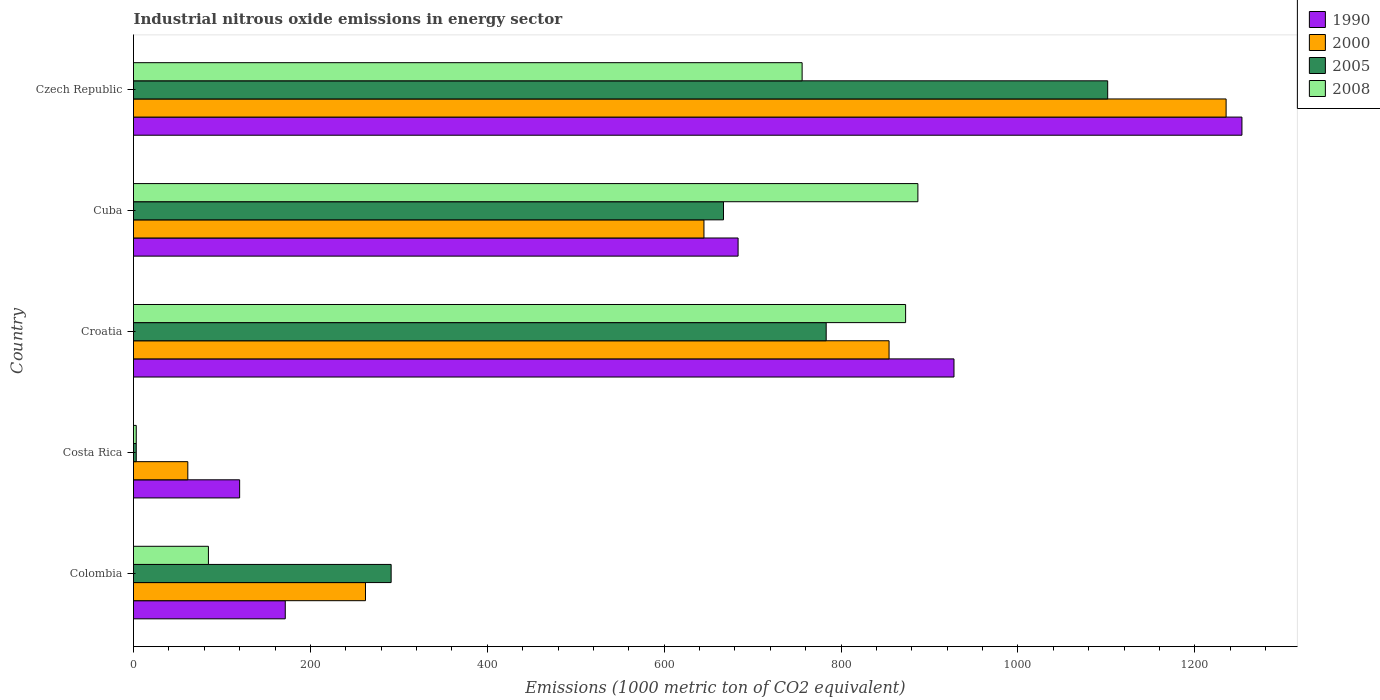How many different coloured bars are there?
Your response must be concise. 4. How many groups of bars are there?
Make the answer very short. 5. Are the number of bars on each tick of the Y-axis equal?
Your response must be concise. Yes. How many bars are there on the 5th tick from the top?
Provide a succinct answer. 4. What is the amount of industrial nitrous oxide emitted in 2005 in Croatia?
Offer a very short reply. 783.2. Across all countries, what is the maximum amount of industrial nitrous oxide emitted in 2005?
Offer a terse response. 1101.5. In which country was the amount of industrial nitrous oxide emitted in 1990 maximum?
Give a very brief answer. Czech Republic. In which country was the amount of industrial nitrous oxide emitted in 2000 minimum?
Your response must be concise. Costa Rica. What is the total amount of industrial nitrous oxide emitted in 1990 in the graph?
Give a very brief answer. 3156.2. What is the difference between the amount of industrial nitrous oxide emitted in 2008 in Colombia and that in Costa Rica?
Offer a very short reply. 81.6. What is the difference between the amount of industrial nitrous oxide emitted in 2000 in Croatia and the amount of industrial nitrous oxide emitted in 2008 in Cuba?
Your answer should be compact. -32.6. What is the average amount of industrial nitrous oxide emitted in 1990 per country?
Make the answer very short. 631.24. What is the difference between the amount of industrial nitrous oxide emitted in 1990 and amount of industrial nitrous oxide emitted in 2000 in Colombia?
Offer a terse response. -90.7. In how many countries, is the amount of industrial nitrous oxide emitted in 2008 greater than 1240 1000 metric ton?
Ensure brevity in your answer.  0. What is the ratio of the amount of industrial nitrous oxide emitted in 2008 in Costa Rica to that in Croatia?
Provide a short and direct response. 0. Is the difference between the amount of industrial nitrous oxide emitted in 1990 in Croatia and Cuba greater than the difference between the amount of industrial nitrous oxide emitted in 2000 in Croatia and Cuba?
Offer a very short reply. Yes. What is the difference between the highest and the second highest amount of industrial nitrous oxide emitted in 1990?
Provide a short and direct response. 325.6. What is the difference between the highest and the lowest amount of industrial nitrous oxide emitted in 2000?
Give a very brief answer. 1174. Is the sum of the amount of industrial nitrous oxide emitted in 2000 in Croatia and Czech Republic greater than the maximum amount of industrial nitrous oxide emitted in 2005 across all countries?
Give a very brief answer. Yes. What does the 3rd bar from the bottom in Colombia represents?
Keep it short and to the point. 2005. What is the difference between two consecutive major ticks on the X-axis?
Give a very brief answer. 200. What is the title of the graph?
Ensure brevity in your answer.  Industrial nitrous oxide emissions in energy sector. Does "1966" appear as one of the legend labels in the graph?
Provide a succinct answer. No. What is the label or title of the X-axis?
Provide a short and direct response. Emissions (1000 metric ton of CO2 equivalent). What is the label or title of the Y-axis?
Your response must be concise. Country. What is the Emissions (1000 metric ton of CO2 equivalent) of 1990 in Colombia?
Provide a succinct answer. 171.6. What is the Emissions (1000 metric ton of CO2 equivalent) in 2000 in Colombia?
Make the answer very short. 262.3. What is the Emissions (1000 metric ton of CO2 equivalent) of 2005 in Colombia?
Your answer should be very brief. 291.3. What is the Emissions (1000 metric ton of CO2 equivalent) of 2008 in Colombia?
Give a very brief answer. 84.7. What is the Emissions (1000 metric ton of CO2 equivalent) in 1990 in Costa Rica?
Provide a short and direct response. 120. What is the Emissions (1000 metric ton of CO2 equivalent) of 2000 in Costa Rica?
Your answer should be compact. 61.4. What is the Emissions (1000 metric ton of CO2 equivalent) in 1990 in Croatia?
Give a very brief answer. 927.7. What is the Emissions (1000 metric ton of CO2 equivalent) in 2000 in Croatia?
Provide a short and direct response. 854.3. What is the Emissions (1000 metric ton of CO2 equivalent) in 2005 in Croatia?
Provide a short and direct response. 783.2. What is the Emissions (1000 metric ton of CO2 equivalent) in 2008 in Croatia?
Provide a short and direct response. 873. What is the Emissions (1000 metric ton of CO2 equivalent) in 1990 in Cuba?
Provide a short and direct response. 683.6. What is the Emissions (1000 metric ton of CO2 equivalent) of 2000 in Cuba?
Make the answer very short. 645. What is the Emissions (1000 metric ton of CO2 equivalent) in 2005 in Cuba?
Ensure brevity in your answer.  667.1. What is the Emissions (1000 metric ton of CO2 equivalent) of 2008 in Cuba?
Your response must be concise. 886.9. What is the Emissions (1000 metric ton of CO2 equivalent) in 1990 in Czech Republic?
Make the answer very short. 1253.3. What is the Emissions (1000 metric ton of CO2 equivalent) of 2000 in Czech Republic?
Your answer should be very brief. 1235.4. What is the Emissions (1000 metric ton of CO2 equivalent) of 2005 in Czech Republic?
Your answer should be very brief. 1101.5. What is the Emissions (1000 metric ton of CO2 equivalent) in 2008 in Czech Republic?
Keep it short and to the point. 756. Across all countries, what is the maximum Emissions (1000 metric ton of CO2 equivalent) in 1990?
Your answer should be compact. 1253.3. Across all countries, what is the maximum Emissions (1000 metric ton of CO2 equivalent) in 2000?
Offer a terse response. 1235.4. Across all countries, what is the maximum Emissions (1000 metric ton of CO2 equivalent) in 2005?
Give a very brief answer. 1101.5. Across all countries, what is the maximum Emissions (1000 metric ton of CO2 equivalent) of 2008?
Provide a short and direct response. 886.9. Across all countries, what is the minimum Emissions (1000 metric ton of CO2 equivalent) in 1990?
Provide a succinct answer. 120. Across all countries, what is the minimum Emissions (1000 metric ton of CO2 equivalent) of 2000?
Offer a terse response. 61.4. Across all countries, what is the minimum Emissions (1000 metric ton of CO2 equivalent) of 2008?
Give a very brief answer. 3.1. What is the total Emissions (1000 metric ton of CO2 equivalent) in 1990 in the graph?
Keep it short and to the point. 3156.2. What is the total Emissions (1000 metric ton of CO2 equivalent) of 2000 in the graph?
Your response must be concise. 3058.4. What is the total Emissions (1000 metric ton of CO2 equivalent) in 2005 in the graph?
Offer a terse response. 2846.2. What is the total Emissions (1000 metric ton of CO2 equivalent) in 2008 in the graph?
Give a very brief answer. 2603.7. What is the difference between the Emissions (1000 metric ton of CO2 equivalent) in 1990 in Colombia and that in Costa Rica?
Give a very brief answer. 51.6. What is the difference between the Emissions (1000 metric ton of CO2 equivalent) of 2000 in Colombia and that in Costa Rica?
Make the answer very short. 200.9. What is the difference between the Emissions (1000 metric ton of CO2 equivalent) in 2005 in Colombia and that in Costa Rica?
Give a very brief answer. 288.2. What is the difference between the Emissions (1000 metric ton of CO2 equivalent) of 2008 in Colombia and that in Costa Rica?
Provide a succinct answer. 81.6. What is the difference between the Emissions (1000 metric ton of CO2 equivalent) in 1990 in Colombia and that in Croatia?
Your response must be concise. -756.1. What is the difference between the Emissions (1000 metric ton of CO2 equivalent) in 2000 in Colombia and that in Croatia?
Offer a very short reply. -592. What is the difference between the Emissions (1000 metric ton of CO2 equivalent) of 2005 in Colombia and that in Croatia?
Provide a short and direct response. -491.9. What is the difference between the Emissions (1000 metric ton of CO2 equivalent) in 2008 in Colombia and that in Croatia?
Ensure brevity in your answer.  -788.3. What is the difference between the Emissions (1000 metric ton of CO2 equivalent) in 1990 in Colombia and that in Cuba?
Give a very brief answer. -512. What is the difference between the Emissions (1000 metric ton of CO2 equivalent) of 2000 in Colombia and that in Cuba?
Make the answer very short. -382.7. What is the difference between the Emissions (1000 metric ton of CO2 equivalent) of 2005 in Colombia and that in Cuba?
Offer a very short reply. -375.8. What is the difference between the Emissions (1000 metric ton of CO2 equivalent) in 2008 in Colombia and that in Cuba?
Make the answer very short. -802.2. What is the difference between the Emissions (1000 metric ton of CO2 equivalent) of 1990 in Colombia and that in Czech Republic?
Ensure brevity in your answer.  -1081.7. What is the difference between the Emissions (1000 metric ton of CO2 equivalent) in 2000 in Colombia and that in Czech Republic?
Ensure brevity in your answer.  -973.1. What is the difference between the Emissions (1000 metric ton of CO2 equivalent) in 2005 in Colombia and that in Czech Republic?
Provide a short and direct response. -810.2. What is the difference between the Emissions (1000 metric ton of CO2 equivalent) of 2008 in Colombia and that in Czech Republic?
Ensure brevity in your answer.  -671.3. What is the difference between the Emissions (1000 metric ton of CO2 equivalent) of 1990 in Costa Rica and that in Croatia?
Offer a very short reply. -807.7. What is the difference between the Emissions (1000 metric ton of CO2 equivalent) of 2000 in Costa Rica and that in Croatia?
Your response must be concise. -792.9. What is the difference between the Emissions (1000 metric ton of CO2 equivalent) in 2005 in Costa Rica and that in Croatia?
Provide a succinct answer. -780.1. What is the difference between the Emissions (1000 metric ton of CO2 equivalent) in 2008 in Costa Rica and that in Croatia?
Your response must be concise. -869.9. What is the difference between the Emissions (1000 metric ton of CO2 equivalent) of 1990 in Costa Rica and that in Cuba?
Make the answer very short. -563.6. What is the difference between the Emissions (1000 metric ton of CO2 equivalent) in 2000 in Costa Rica and that in Cuba?
Your answer should be compact. -583.6. What is the difference between the Emissions (1000 metric ton of CO2 equivalent) in 2005 in Costa Rica and that in Cuba?
Make the answer very short. -664. What is the difference between the Emissions (1000 metric ton of CO2 equivalent) in 2008 in Costa Rica and that in Cuba?
Provide a succinct answer. -883.8. What is the difference between the Emissions (1000 metric ton of CO2 equivalent) in 1990 in Costa Rica and that in Czech Republic?
Give a very brief answer. -1133.3. What is the difference between the Emissions (1000 metric ton of CO2 equivalent) in 2000 in Costa Rica and that in Czech Republic?
Provide a short and direct response. -1174. What is the difference between the Emissions (1000 metric ton of CO2 equivalent) in 2005 in Costa Rica and that in Czech Republic?
Your answer should be compact. -1098.4. What is the difference between the Emissions (1000 metric ton of CO2 equivalent) of 2008 in Costa Rica and that in Czech Republic?
Provide a short and direct response. -752.9. What is the difference between the Emissions (1000 metric ton of CO2 equivalent) in 1990 in Croatia and that in Cuba?
Your response must be concise. 244.1. What is the difference between the Emissions (1000 metric ton of CO2 equivalent) in 2000 in Croatia and that in Cuba?
Provide a short and direct response. 209.3. What is the difference between the Emissions (1000 metric ton of CO2 equivalent) of 2005 in Croatia and that in Cuba?
Your response must be concise. 116.1. What is the difference between the Emissions (1000 metric ton of CO2 equivalent) of 2008 in Croatia and that in Cuba?
Provide a short and direct response. -13.9. What is the difference between the Emissions (1000 metric ton of CO2 equivalent) in 1990 in Croatia and that in Czech Republic?
Make the answer very short. -325.6. What is the difference between the Emissions (1000 metric ton of CO2 equivalent) of 2000 in Croatia and that in Czech Republic?
Provide a succinct answer. -381.1. What is the difference between the Emissions (1000 metric ton of CO2 equivalent) in 2005 in Croatia and that in Czech Republic?
Make the answer very short. -318.3. What is the difference between the Emissions (1000 metric ton of CO2 equivalent) of 2008 in Croatia and that in Czech Republic?
Provide a succinct answer. 117. What is the difference between the Emissions (1000 metric ton of CO2 equivalent) of 1990 in Cuba and that in Czech Republic?
Your answer should be compact. -569.7. What is the difference between the Emissions (1000 metric ton of CO2 equivalent) of 2000 in Cuba and that in Czech Republic?
Keep it short and to the point. -590.4. What is the difference between the Emissions (1000 metric ton of CO2 equivalent) of 2005 in Cuba and that in Czech Republic?
Offer a very short reply. -434.4. What is the difference between the Emissions (1000 metric ton of CO2 equivalent) in 2008 in Cuba and that in Czech Republic?
Provide a short and direct response. 130.9. What is the difference between the Emissions (1000 metric ton of CO2 equivalent) of 1990 in Colombia and the Emissions (1000 metric ton of CO2 equivalent) of 2000 in Costa Rica?
Ensure brevity in your answer.  110.2. What is the difference between the Emissions (1000 metric ton of CO2 equivalent) of 1990 in Colombia and the Emissions (1000 metric ton of CO2 equivalent) of 2005 in Costa Rica?
Offer a very short reply. 168.5. What is the difference between the Emissions (1000 metric ton of CO2 equivalent) in 1990 in Colombia and the Emissions (1000 metric ton of CO2 equivalent) in 2008 in Costa Rica?
Keep it short and to the point. 168.5. What is the difference between the Emissions (1000 metric ton of CO2 equivalent) in 2000 in Colombia and the Emissions (1000 metric ton of CO2 equivalent) in 2005 in Costa Rica?
Ensure brevity in your answer.  259.2. What is the difference between the Emissions (1000 metric ton of CO2 equivalent) in 2000 in Colombia and the Emissions (1000 metric ton of CO2 equivalent) in 2008 in Costa Rica?
Your answer should be compact. 259.2. What is the difference between the Emissions (1000 metric ton of CO2 equivalent) of 2005 in Colombia and the Emissions (1000 metric ton of CO2 equivalent) of 2008 in Costa Rica?
Keep it short and to the point. 288.2. What is the difference between the Emissions (1000 metric ton of CO2 equivalent) in 1990 in Colombia and the Emissions (1000 metric ton of CO2 equivalent) in 2000 in Croatia?
Give a very brief answer. -682.7. What is the difference between the Emissions (1000 metric ton of CO2 equivalent) of 1990 in Colombia and the Emissions (1000 metric ton of CO2 equivalent) of 2005 in Croatia?
Your answer should be very brief. -611.6. What is the difference between the Emissions (1000 metric ton of CO2 equivalent) in 1990 in Colombia and the Emissions (1000 metric ton of CO2 equivalent) in 2008 in Croatia?
Make the answer very short. -701.4. What is the difference between the Emissions (1000 metric ton of CO2 equivalent) of 2000 in Colombia and the Emissions (1000 metric ton of CO2 equivalent) of 2005 in Croatia?
Your answer should be compact. -520.9. What is the difference between the Emissions (1000 metric ton of CO2 equivalent) in 2000 in Colombia and the Emissions (1000 metric ton of CO2 equivalent) in 2008 in Croatia?
Offer a terse response. -610.7. What is the difference between the Emissions (1000 metric ton of CO2 equivalent) of 2005 in Colombia and the Emissions (1000 metric ton of CO2 equivalent) of 2008 in Croatia?
Give a very brief answer. -581.7. What is the difference between the Emissions (1000 metric ton of CO2 equivalent) of 1990 in Colombia and the Emissions (1000 metric ton of CO2 equivalent) of 2000 in Cuba?
Provide a short and direct response. -473.4. What is the difference between the Emissions (1000 metric ton of CO2 equivalent) of 1990 in Colombia and the Emissions (1000 metric ton of CO2 equivalent) of 2005 in Cuba?
Ensure brevity in your answer.  -495.5. What is the difference between the Emissions (1000 metric ton of CO2 equivalent) in 1990 in Colombia and the Emissions (1000 metric ton of CO2 equivalent) in 2008 in Cuba?
Your answer should be compact. -715.3. What is the difference between the Emissions (1000 metric ton of CO2 equivalent) in 2000 in Colombia and the Emissions (1000 metric ton of CO2 equivalent) in 2005 in Cuba?
Offer a very short reply. -404.8. What is the difference between the Emissions (1000 metric ton of CO2 equivalent) in 2000 in Colombia and the Emissions (1000 metric ton of CO2 equivalent) in 2008 in Cuba?
Make the answer very short. -624.6. What is the difference between the Emissions (1000 metric ton of CO2 equivalent) in 2005 in Colombia and the Emissions (1000 metric ton of CO2 equivalent) in 2008 in Cuba?
Offer a very short reply. -595.6. What is the difference between the Emissions (1000 metric ton of CO2 equivalent) in 1990 in Colombia and the Emissions (1000 metric ton of CO2 equivalent) in 2000 in Czech Republic?
Make the answer very short. -1063.8. What is the difference between the Emissions (1000 metric ton of CO2 equivalent) in 1990 in Colombia and the Emissions (1000 metric ton of CO2 equivalent) in 2005 in Czech Republic?
Make the answer very short. -929.9. What is the difference between the Emissions (1000 metric ton of CO2 equivalent) of 1990 in Colombia and the Emissions (1000 metric ton of CO2 equivalent) of 2008 in Czech Republic?
Offer a very short reply. -584.4. What is the difference between the Emissions (1000 metric ton of CO2 equivalent) in 2000 in Colombia and the Emissions (1000 metric ton of CO2 equivalent) in 2005 in Czech Republic?
Give a very brief answer. -839.2. What is the difference between the Emissions (1000 metric ton of CO2 equivalent) of 2000 in Colombia and the Emissions (1000 metric ton of CO2 equivalent) of 2008 in Czech Republic?
Provide a short and direct response. -493.7. What is the difference between the Emissions (1000 metric ton of CO2 equivalent) of 2005 in Colombia and the Emissions (1000 metric ton of CO2 equivalent) of 2008 in Czech Republic?
Offer a terse response. -464.7. What is the difference between the Emissions (1000 metric ton of CO2 equivalent) of 1990 in Costa Rica and the Emissions (1000 metric ton of CO2 equivalent) of 2000 in Croatia?
Provide a short and direct response. -734.3. What is the difference between the Emissions (1000 metric ton of CO2 equivalent) in 1990 in Costa Rica and the Emissions (1000 metric ton of CO2 equivalent) in 2005 in Croatia?
Offer a terse response. -663.2. What is the difference between the Emissions (1000 metric ton of CO2 equivalent) of 1990 in Costa Rica and the Emissions (1000 metric ton of CO2 equivalent) of 2008 in Croatia?
Provide a succinct answer. -753. What is the difference between the Emissions (1000 metric ton of CO2 equivalent) in 2000 in Costa Rica and the Emissions (1000 metric ton of CO2 equivalent) in 2005 in Croatia?
Provide a succinct answer. -721.8. What is the difference between the Emissions (1000 metric ton of CO2 equivalent) of 2000 in Costa Rica and the Emissions (1000 metric ton of CO2 equivalent) of 2008 in Croatia?
Ensure brevity in your answer.  -811.6. What is the difference between the Emissions (1000 metric ton of CO2 equivalent) of 2005 in Costa Rica and the Emissions (1000 metric ton of CO2 equivalent) of 2008 in Croatia?
Your response must be concise. -869.9. What is the difference between the Emissions (1000 metric ton of CO2 equivalent) in 1990 in Costa Rica and the Emissions (1000 metric ton of CO2 equivalent) in 2000 in Cuba?
Offer a terse response. -525. What is the difference between the Emissions (1000 metric ton of CO2 equivalent) of 1990 in Costa Rica and the Emissions (1000 metric ton of CO2 equivalent) of 2005 in Cuba?
Keep it short and to the point. -547.1. What is the difference between the Emissions (1000 metric ton of CO2 equivalent) in 1990 in Costa Rica and the Emissions (1000 metric ton of CO2 equivalent) in 2008 in Cuba?
Offer a terse response. -766.9. What is the difference between the Emissions (1000 metric ton of CO2 equivalent) of 2000 in Costa Rica and the Emissions (1000 metric ton of CO2 equivalent) of 2005 in Cuba?
Keep it short and to the point. -605.7. What is the difference between the Emissions (1000 metric ton of CO2 equivalent) in 2000 in Costa Rica and the Emissions (1000 metric ton of CO2 equivalent) in 2008 in Cuba?
Provide a succinct answer. -825.5. What is the difference between the Emissions (1000 metric ton of CO2 equivalent) in 2005 in Costa Rica and the Emissions (1000 metric ton of CO2 equivalent) in 2008 in Cuba?
Give a very brief answer. -883.8. What is the difference between the Emissions (1000 metric ton of CO2 equivalent) of 1990 in Costa Rica and the Emissions (1000 metric ton of CO2 equivalent) of 2000 in Czech Republic?
Your response must be concise. -1115.4. What is the difference between the Emissions (1000 metric ton of CO2 equivalent) of 1990 in Costa Rica and the Emissions (1000 metric ton of CO2 equivalent) of 2005 in Czech Republic?
Offer a terse response. -981.5. What is the difference between the Emissions (1000 metric ton of CO2 equivalent) of 1990 in Costa Rica and the Emissions (1000 metric ton of CO2 equivalent) of 2008 in Czech Republic?
Your answer should be compact. -636. What is the difference between the Emissions (1000 metric ton of CO2 equivalent) of 2000 in Costa Rica and the Emissions (1000 metric ton of CO2 equivalent) of 2005 in Czech Republic?
Your response must be concise. -1040.1. What is the difference between the Emissions (1000 metric ton of CO2 equivalent) of 2000 in Costa Rica and the Emissions (1000 metric ton of CO2 equivalent) of 2008 in Czech Republic?
Provide a short and direct response. -694.6. What is the difference between the Emissions (1000 metric ton of CO2 equivalent) in 2005 in Costa Rica and the Emissions (1000 metric ton of CO2 equivalent) in 2008 in Czech Republic?
Your answer should be very brief. -752.9. What is the difference between the Emissions (1000 metric ton of CO2 equivalent) of 1990 in Croatia and the Emissions (1000 metric ton of CO2 equivalent) of 2000 in Cuba?
Your answer should be compact. 282.7. What is the difference between the Emissions (1000 metric ton of CO2 equivalent) of 1990 in Croatia and the Emissions (1000 metric ton of CO2 equivalent) of 2005 in Cuba?
Make the answer very short. 260.6. What is the difference between the Emissions (1000 metric ton of CO2 equivalent) of 1990 in Croatia and the Emissions (1000 metric ton of CO2 equivalent) of 2008 in Cuba?
Give a very brief answer. 40.8. What is the difference between the Emissions (1000 metric ton of CO2 equivalent) in 2000 in Croatia and the Emissions (1000 metric ton of CO2 equivalent) in 2005 in Cuba?
Give a very brief answer. 187.2. What is the difference between the Emissions (1000 metric ton of CO2 equivalent) of 2000 in Croatia and the Emissions (1000 metric ton of CO2 equivalent) of 2008 in Cuba?
Offer a terse response. -32.6. What is the difference between the Emissions (1000 metric ton of CO2 equivalent) of 2005 in Croatia and the Emissions (1000 metric ton of CO2 equivalent) of 2008 in Cuba?
Provide a succinct answer. -103.7. What is the difference between the Emissions (1000 metric ton of CO2 equivalent) in 1990 in Croatia and the Emissions (1000 metric ton of CO2 equivalent) in 2000 in Czech Republic?
Your response must be concise. -307.7. What is the difference between the Emissions (1000 metric ton of CO2 equivalent) in 1990 in Croatia and the Emissions (1000 metric ton of CO2 equivalent) in 2005 in Czech Republic?
Your response must be concise. -173.8. What is the difference between the Emissions (1000 metric ton of CO2 equivalent) in 1990 in Croatia and the Emissions (1000 metric ton of CO2 equivalent) in 2008 in Czech Republic?
Keep it short and to the point. 171.7. What is the difference between the Emissions (1000 metric ton of CO2 equivalent) in 2000 in Croatia and the Emissions (1000 metric ton of CO2 equivalent) in 2005 in Czech Republic?
Provide a short and direct response. -247.2. What is the difference between the Emissions (1000 metric ton of CO2 equivalent) of 2000 in Croatia and the Emissions (1000 metric ton of CO2 equivalent) of 2008 in Czech Republic?
Keep it short and to the point. 98.3. What is the difference between the Emissions (1000 metric ton of CO2 equivalent) of 2005 in Croatia and the Emissions (1000 metric ton of CO2 equivalent) of 2008 in Czech Republic?
Offer a terse response. 27.2. What is the difference between the Emissions (1000 metric ton of CO2 equivalent) of 1990 in Cuba and the Emissions (1000 metric ton of CO2 equivalent) of 2000 in Czech Republic?
Give a very brief answer. -551.8. What is the difference between the Emissions (1000 metric ton of CO2 equivalent) in 1990 in Cuba and the Emissions (1000 metric ton of CO2 equivalent) in 2005 in Czech Republic?
Provide a short and direct response. -417.9. What is the difference between the Emissions (1000 metric ton of CO2 equivalent) of 1990 in Cuba and the Emissions (1000 metric ton of CO2 equivalent) of 2008 in Czech Republic?
Give a very brief answer. -72.4. What is the difference between the Emissions (1000 metric ton of CO2 equivalent) of 2000 in Cuba and the Emissions (1000 metric ton of CO2 equivalent) of 2005 in Czech Republic?
Offer a very short reply. -456.5. What is the difference between the Emissions (1000 metric ton of CO2 equivalent) of 2000 in Cuba and the Emissions (1000 metric ton of CO2 equivalent) of 2008 in Czech Republic?
Offer a terse response. -111. What is the difference between the Emissions (1000 metric ton of CO2 equivalent) in 2005 in Cuba and the Emissions (1000 metric ton of CO2 equivalent) in 2008 in Czech Republic?
Your answer should be compact. -88.9. What is the average Emissions (1000 metric ton of CO2 equivalent) in 1990 per country?
Offer a terse response. 631.24. What is the average Emissions (1000 metric ton of CO2 equivalent) of 2000 per country?
Make the answer very short. 611.68. What is the average Emissions (1000 metric ton of CO2 equivalent) of 2005 per country?
Provide a succinct answer. 569.24. What is the average Emissions (1000 metric ton of CO2 equivalent) in 2008 per country?
Offer a terse response. 520.74. What is the difference between the Emissions (1000 metric ton of CO2 equivalent) in 1990 and Emissions (1000 metric ton of CO2 equivalent) in 2000 in Colombia?
Your answer should be compact. -90.7. What is the difference between the Emissions (1000 metric ton of CO2 equivalent) in 1990 and Emissions (1000 metric ton of CO2 equivalent) in 2005 in Colombia?
Your answer should be compact. -119.7. What is the difference between the Emissions (1000 metric ton of CO2 equivalent) in 1990 and Emissions (1000 metric ton of CO2 equivalent) in 2008 in Colombia?
Your answer should be compact. 86.9. What is the difference between the Emissions (1000 metric ton of CO2 equivalent) in 2000 and Emissions (1000 metric ton of CO2 equivalent) in 2008 in Colombia?
Your response must be concise. 177.6. What is the difference between the Emissions (1000 metric ton of CO2 equivalent) of 2005 and Emissions (1000 metric ton of CO2 equivalent) of 2008 in Colombia?
Provide a succinct answer. 206.6. What is the difference between the Emissions (1000 metric ton of CO2 equivalent) in 1990 and Emissions (1000 metric ton of CO2 equivalent) in 2000 in Costa Rica?
Your answer should be very brief. 58.6. What is the difference between the Emissions (1000 metric ton of CO2 equivalent) in 1990 and Emissions (1000 metric ton of CO2 equivalent) in 2005 in Costa Rica?
Give a very brief answer. 116.9. What is the difference between the Emissions (1000 metric ton of CO2 equivalent) in 1990 and Emissions (1000 metric ton of CO2 equivalent) in 2008 in Costa Rica?
Provide a short and direct response. 116.9. What is the difference between the Emissions (1000 metric ton of CO2 equivalent) in 2000 and Emissions (1000 metric ton of CO2 equivalent) in 2005 in Costa Rica?
Offer a terse response. 58.3. What is the difference between the Emissions (1000 metric ton of CO2 equivalent) of 2000 and Emissions (1000 metric ton of CO2 equivalent) of 2008 in Costa Rica?
Offer a very short reply. 58.3. What is the difference between the Emissions (1000 metric ton of CO2 equivalent) of 1990 and Emissions (1000 metric ton of CO2 equivalent) of 2000 in Croatia?
Offer a very short reply. 73.4. What is the difference between the Emissions (1000 metric ton of CO2 equivalent) in 1990 and Emissions (1000 metric ton of CO2 equivalent) in 2005 in Croatia?
Ensure brevity in your answer.  144.5. What is the difference between the Emissions (1000 metric ton of CO2 equivalent) in 1990 and Emissions (1000 metric ton of CO2 equivalent) in 2008 in Croatia?
Your answer should be very brief. 54.7. What is the difference between the Emissions (1000 metric ton of CO2 equivalent) in 2000 and Emissions (1000 metric ton of CO2 equivalent) in 2005 in Croatia?
Offer a very short reply. 71.1. What is the difference between the Emissions (1000 metric ton of CO2 equivalent) of 2000 and Emissions (1000 metric ton of CO2 equivalent) of 2008 in Croatia?
Provide a short and direct response. -18.7. What is the difference between the Emissions (1000 metric ton of CO2 equivalent) in 2005 and Emissions (1000 metric ton of CO2 equivalent) in 2008 in Croatia?
Provide a succinct answer. -89.8. What is the difference between the Emissions (1000 metric ton of CO2 equivalent) of 1990 and Emissions (1000 metric ton of CO2 equivalent) of 2000 in Cuba?
Offer a very short reply. 38.6. What is the difference between the Emissions (1000 metric ton of CO2 equivalent) of 1990 and Emissions (1000 metric ton of CO2 equivalent) of 2008 in Cuba?
Provide a short and direct response. -203.3. What is the difference between the Emissions (1000 metric ton of CO2 equivalent) of 2000 and Emissions (1000 metric ton of CO2 equivalent) of 2005 in Cuba?
Ensure brevity in your answer.  -22.1. What is the difference between the Emissions (1000 metric ton of CO2 equivalent) of 2000 and Emissions (1000 metric ton of CO2 equivalent) of 2008 in Cuba?
Make the answer very short. -241.9. What is the difference between the Emissions (1000 metric ton of CO2 equivalent) in 2005 and Emissions (1000 metric ton of CO2 equivalent) in 2008 in Cuba?
Your response must be concise. -219.8. What is the difference between the Emissions (1000 metric ton of CO2 equivalent) in 1990 and Emissions (1000 metric ton of CO2 equivalent) in 2005 in Czech Republic?
Keep it short and to the point. 151.8. What is the difference between the Emissions (1000 metric ton of CO2 equivalent) of 1990 and Emissions (1000 metric ton of CO2 equivalent) of 2008 in Czech Republic?
Offer a terse response. 497.3. What is the difference between the Emissions (1000 metric ton of CO2 equivalent) in 2000 and Emissions (1000 metric ton of CO2 equivalent) in 2005 in Czech Republic?
Offer a very short reply. 133.9. What is the difference between the Emissions (1000 metric ton of CO2 equivalent) of 2000 and Emissions (1000 metric ton of CO2 equivalent) of 2008 in Czech Republic?
Provide a short and direct response. 479.4. What is the difference between the Emissions (1000 metric ton of CO2 equivalent) of 2005 and Emissions (1000 metric ton of CO2 equivalent) of 2008 in Czech Republic?
Offer a very short reply. 345.5. What is the ratio of the Emissions (1000 metric ton of CO2 equivalent) of 1990 in Colombia to that in Costa Rica?
Offer a very short reply. 1.43. What is the ratio of the Emissions (1000 metric ton of CO2 equivalent) of 2000 in Colombia to that in Costa Rica?
Give a very brief answer. 4.27. What is the ratio of the Emissions (1000 metric ton of CO2 equivalent) in 2005 in Colombia to that in Costa Rica?
Ensure brevity in your answer.  93.97. What is the ratio of the Emissions (1000 metric ton of CO2 equivalent) in 2008 in Colombia to that in Costa Rica?
Your answer should be compact. 27.32. What is the ratio of the Emissions (1000 metric ton of CO2 equivalent) of 1990 in Colombia to that in Croatia?
Keep it short and to the point. 0.18. What is the ratio of the Emissions (1000 metric ton of CO2 equivalent) of 2000 in Colombia to that in Croatia?
Offer a terse response. 0.31. What is the ratio of the Emissions (1000 metric ton of CO2 equivalent) in 2005 in Colombia to that in Croatia?
Provide a succinct answer. 0.37. What is the ratio of the Emissions (1000 metric ton of CO2 equivalent) in 2008 in Colombia to that in Croatia?
Make the answer very short. 0.1. What is the ratio of the Emissions (1000 metric ton of CO2 equivalent) in 1990 in Colombia to that in Cuba?
Provide a short and direct response. 0.25. What is the ratio of the Emissions (1000 metric ton of CO2 equivalent) in 2000 in Colombia to that in Cuba?
Provide a succinct answer. 0.41. What is the ratio of the Emissions (1000 metric ton of CO2 equivalent) in 2005 in Colombia to that in Cuba?
Offer a terse response. 0.44. What is the ratio of the Emissions (1000 metric ton of CO2 equivalent) in 2008 in Colombia to that in Cuba?
Provide a succinct answer. 0.1. What is the ratio of the Emissions (1000 metric ton of CO2 equivalent) of 1990 in Colombia to that in Czech Republic?
Ensure brevity in your answer.  0.14. What is the ratio of the Emissions (1000 metric ton of CO2 equivalent) of 2000 in Colombia to that in Czech Republic?
Your answer should be compact. 0.21. What is the ratio of the Emissions (1000 metric ton of CO2 equivalent) in 2005 in Colombia to that in Czech Republic?
Your answer should be compact. 0.26. What is the ratio of the Emissions (1000 metric ton of CO2 equivalent) in 2008 in Colombia to that in Czech Republic?
Your response must be concise. 0.11. What is the ratio of the Emissions (1000 metric ton of CO2 equivalent) of 1990 in Costa Rica to that in Croatia?
Provide a succinct answer. 0.13. What is the ratio of the Emissions (1000 metric ton of CO2 equivalent) in 2000 in Costa Rica to that in Croatia?
Your answer should be very brief. 0.07. What is the ratio of the Emissions (1000 metric ton of CO2 equivalent) in 2005 in Costa Rica to that in Croatia?
Your answer should be compact. 0. What is the ratio of the Emissions (1000 metric ton of CO2 equivalent) of 2008 in Costa Rica to that in Croatia?
Your answer should be compact. 0. What is the ratio of the Emissions (1000 metric ton of CO2 equivalent) of 1990 in Costa Rica to that in Cuba?
Your answer should be compact. 0.18. What is the ratio of the Emissions (1000 metric ton of CO2 equivalent) in 2000 in Costa Rica to that in Cuba?
Give a very brief answer. 0.1. What is the ratio of the Emissions (1000 metric ton of CO2 equivalent) of 2005 in Costa Rica to that in Cuba?
Your answer should be very brief. 0. What is the ratio of the Emissions (1000 metric ton of CO2 equivalent) in 2008 in Costa Rica to that in Cuba?
Your answer should be compact. 0. What is the ratio of the Emissions (1000 metric ton of CO2 equivalent) in 1990 in Costa Rica to that in Czech Republic?
Make the answer very short. 0.1. What is the ratio of the Emissions (1000 metric ton of CO2 equivalent) of 2000 in Costa Rica to that in Czech Republic?
Ensure brevity in your answer.  0.05. What is the ratio of the Emissions (1000 metric ton of CO2 equivalent) in 2005 in Costa Rica to that in Czech Republic?
Your response must be concise. 0. What is the ratio of the Emissions (1000 metric ton of CO2 equivalent) in 2008 in Costa Rica to that in Czech Republic?
Your answer should be compact. 0. What is the ratio of the Emissions (1000 metric ton of CO2 equivalent) of 1990 in Croatia to that in Cuba?
Provide a short and direct response. 1.36. What is the ratio of the Emissions (1000 metric ton of CO2 equivalent) in 2000 in Croatia to that in Cuba?
Give a very brief answer. 1.32. What is the ratio of the Emissions (1000 metric ton of CO2 equivalent) in 2005 in Croatia to that in Cuba?
Your answer should be very brief. 1.17. What is the ratio of the Emissions (1000 metric ton of CO2 equivalent) of 2008 in Croatia to that in Cuba?
Keep it short and to the point. 0.98. What is the ratio of the Emissions (1000 metric ton of CO2 equivalent) of 1990 in Croatia to that in Czech Republic?
Offer a terse response. 0.74. What is the ratio of the Emissions (1000 metric ton of CO2 equivalent) of 2000 in Croatia to that in Czech Republic?
Your answer should be compact. 0.69. What is the ratio of the Emissions (1000 metric ton of CO2 equivalent) in 2005 in Croatia to that in Czech Republic?
Make the answer very short. 0.71. What is the ratio of the Emissions (1000 metric ton of CO2 equivalent) in 2008 in Croatia to that in Czech Republic?
Offer a very short reply. 1.15. What is the ratio of the Emissions (1000 metric ton of CO2 equivalent) in 1990 in Cuba to that in Czech Republic?
Make the answer very short. 0.55. What is the ratio of the Emissions (1000 metric ton of CO2 equivalent) in 2000 in Cuba to that in Czech Republic?
Your answer should be compact. 0.52. What is the ratio of the Emissions (1000 metric ton of CO2 equivalent) in 2005 in Cuba to that in Czech Republic?
Provide a succinct answer. 0.61. What is the ratio of the Emissions (1000 metric ton of CO2 equivalent) in 2008 in Cuba to that in Czech Republic?
Your response must be concise. 1.17. What is the difference between the highest and the second highest Emissions (1000 metric ton of CO2 equivalent) of 1990?
Your answer should be compact. 325.6. What is the difference between the highest and the second highest Emissions (1000 metric ton of CO2 equivalent) in 2000?
Provide a short and direct response. 381.1. What is the difference between the highest and the second highest Emissions (1000 metric ton of CO2 equivalent) of 2005?
Make the answer very short. 318.3. What is the difference between the highest and the lowest Emissions (1000 metric ton of CO2 equivalent) of 1990?
Offer a terse response. 1133.3. What is the difference between the highest and the lowest Emissions (1000 metric ton of CO2 equivalent) of 2000?
Keep it short and to the point. 1174. What is the difference between the highest and the lowest Emissions (1000 metric ton of CO2 equivalent) in 2005?
Offer a terse response. 1098.4. What is the difference between the highest and the lowest Emissions (1000 metric ton of CO2 equivalent) of 2008?
Ensure brevity in your answer.  883.8. 